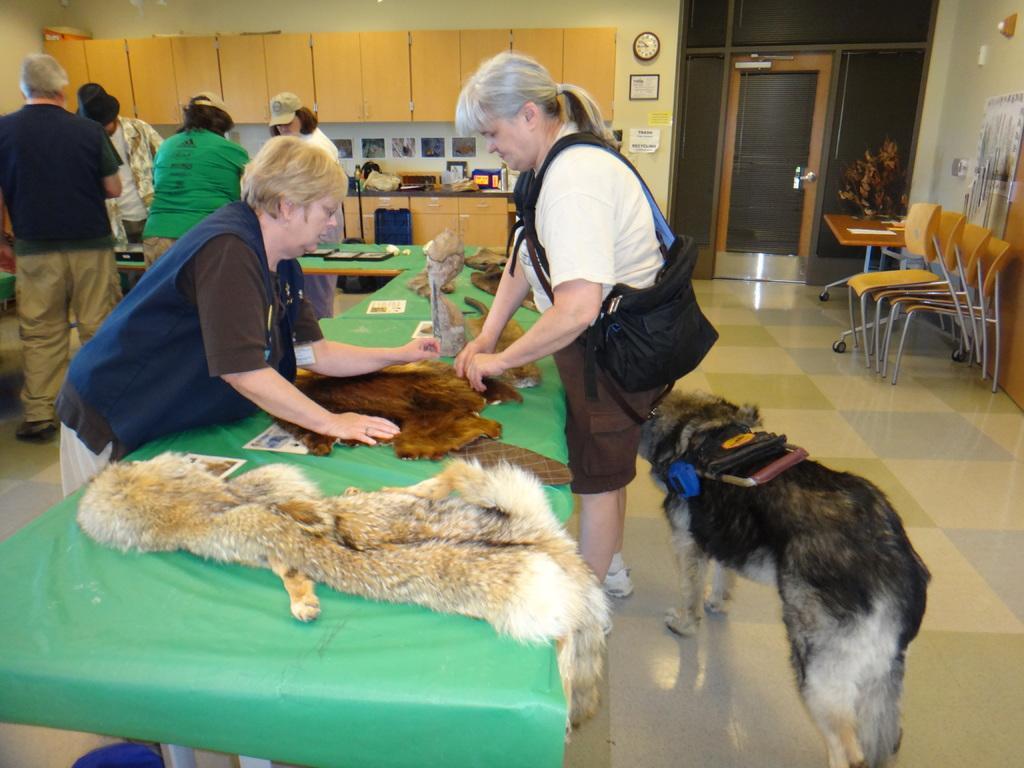Please provide a concise description of this image. In the image we can see there are people who are standing on table. There are flesh and on the floor there is a dog who is standing and there are chairs which are kept on each other and there are other people who are standing at the back. On the wall there is a clock and the tablecloth is in green colour. 